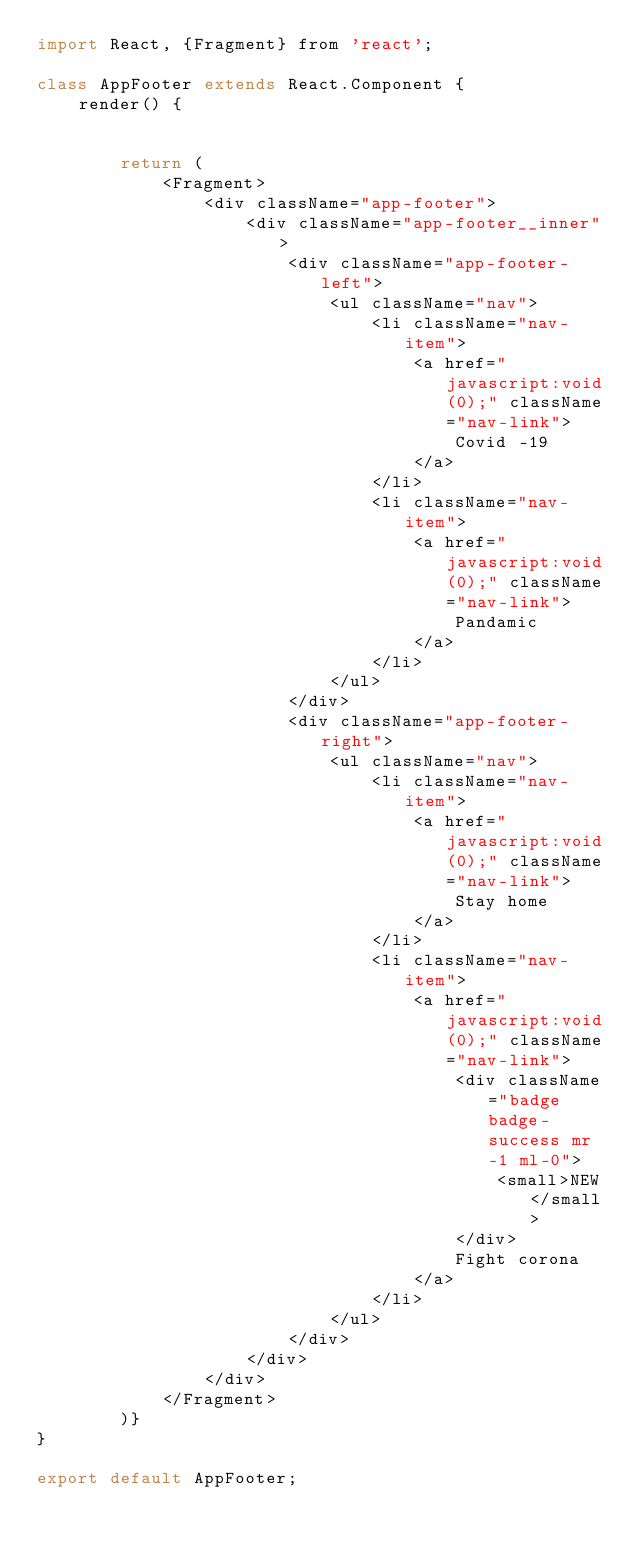Convert code to text. <code><loc_0><loc_0><loc_500><loc_500><_JavaScript_>import React, {Fragment} from 'react';

class AppFooter extends React.Component {
    render() {


        return (
            <Fragment>
                <div className="app-footer">
                    <div className="app-footer__inner">
                        <div className="app-footer-left">
                            <ul className="nav">
                                <li className="nav-item">
                                    <a href="javascript:void(0);" className="nav-link">
                                        Covid -19
                                    </a>
                                </li>
                                <li className="nav-item">
                                    <a href="javascript:void(0);" className="nav-link">
                                        Pandamic
                                    </a>
                                </li>
                            </ul>
                        </div>
                        <div className="app-footer-right">
                            <ul className="nav">
                                <li className="nav-item">
                                    <a href="javascript:void(0);" className="nav-link">
                                        Stay home
                                    </a>
                                </li>
                                <li className="nav-item">
                                    <a href="javascript:void(0);" className="nav-link">
                                        <div className="badge badge-success mr-1 ml-0">
                                            <small>NEW</small>
                                        </div>
                                        Fight corona
                                    </a>
                                </li>
                            </ul>
                        </div>
                    </div>
                </div>
            </Fragment>
        )}
}

export default AppFooter;</code> 